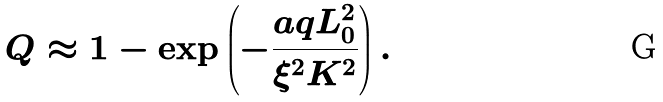<formula> <loc_0><loc_0><loc_500><loc_500>Q \approx 1 - \exp \left ( - \frac { a q L _ { 0 } ^ { 2 } } { \xi ^ { 2 } K ^ { 2 } } \right ) .</formula> 